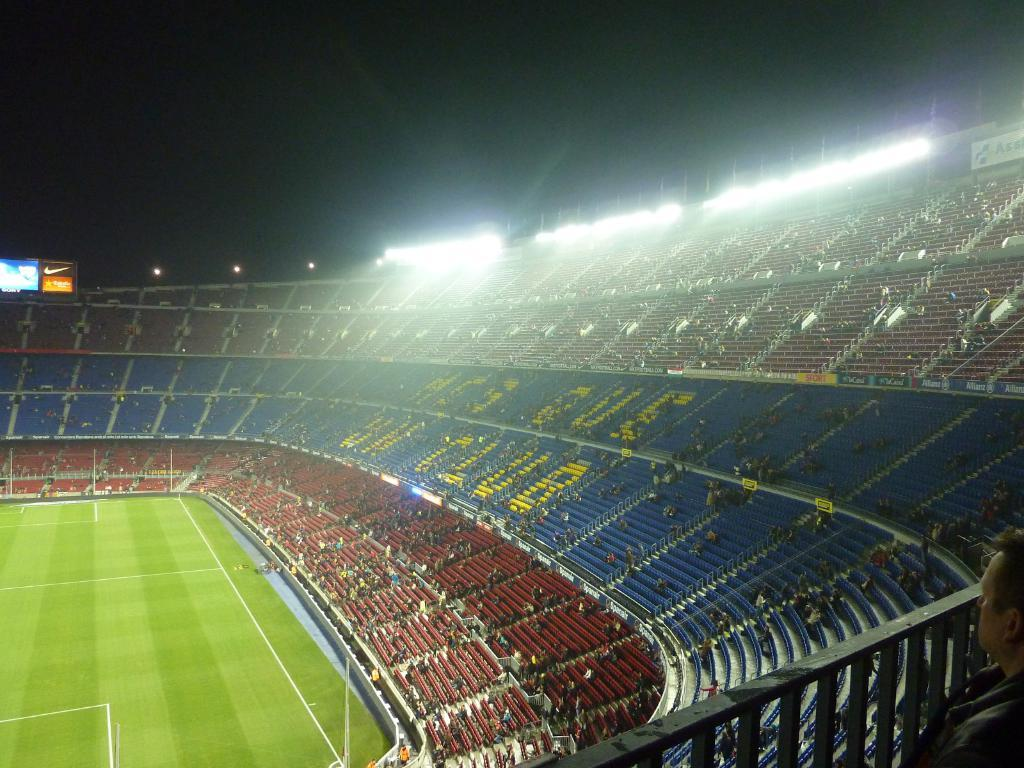What type of structure is the main subject of the image? There is a stadium in the image. What can be found inside the stadium? There are chairs, stairs, name boards, a group of people, lights, and a ground inside the stadium. Can you describe the lighting conditions in the image? The background of the image is dark, but there are lights in the stadium. What type of insect can be seen crawling on the ticket in the image? There is no ticket present in the image, and therefore no insect can be seen crawling on it. 